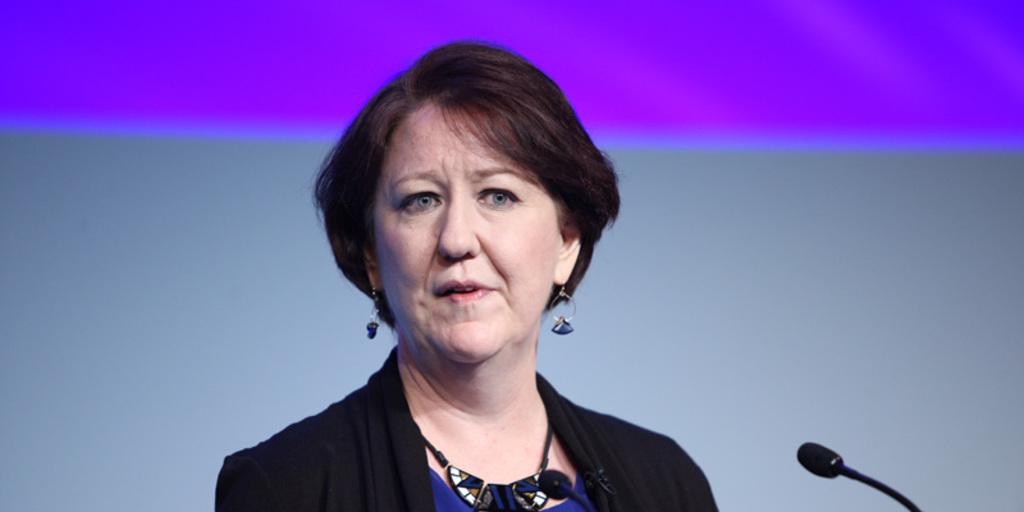Who is the main subject in the image? There is a woman in the image. What is the woman wearing? The woman is wearing a black jacket. What is the woman doing in the image? The woman is speaking in front of a microphone. Can you describe the color combination of the background in the image? The background of the image has a violet and gray color combination. What type of harmony is being discussed by the woman in the image? There is no indication in the image that the woman is discussing harmony or any other specific topic. 